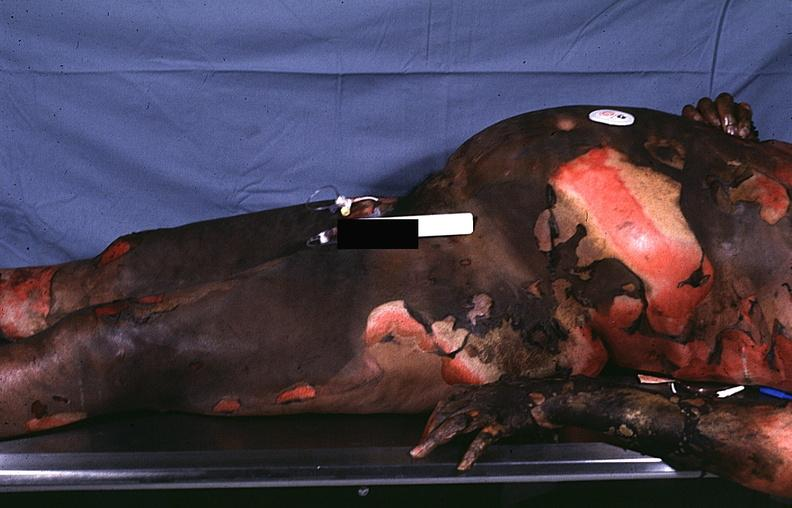where is this?
Answer the question using a single word or phrase. Skin 